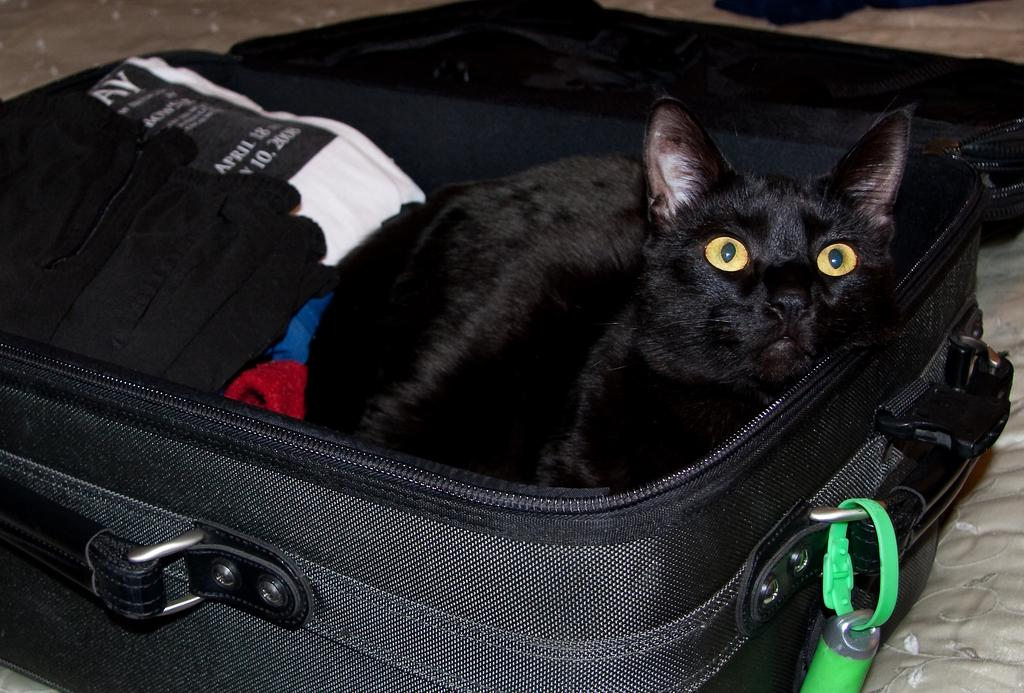What object is visible in the image that people might use for traveling? There is a suitcase in the image. What unexpected item can be found inside the suitcase? A black cat is inside the suitcase. What can be seen on the left side of the suitcase? There are clothes on the left side of the suitcase. What type of berry can be seen growing on the suitcase in the image? There are no berries present on the suitcase in the image. 